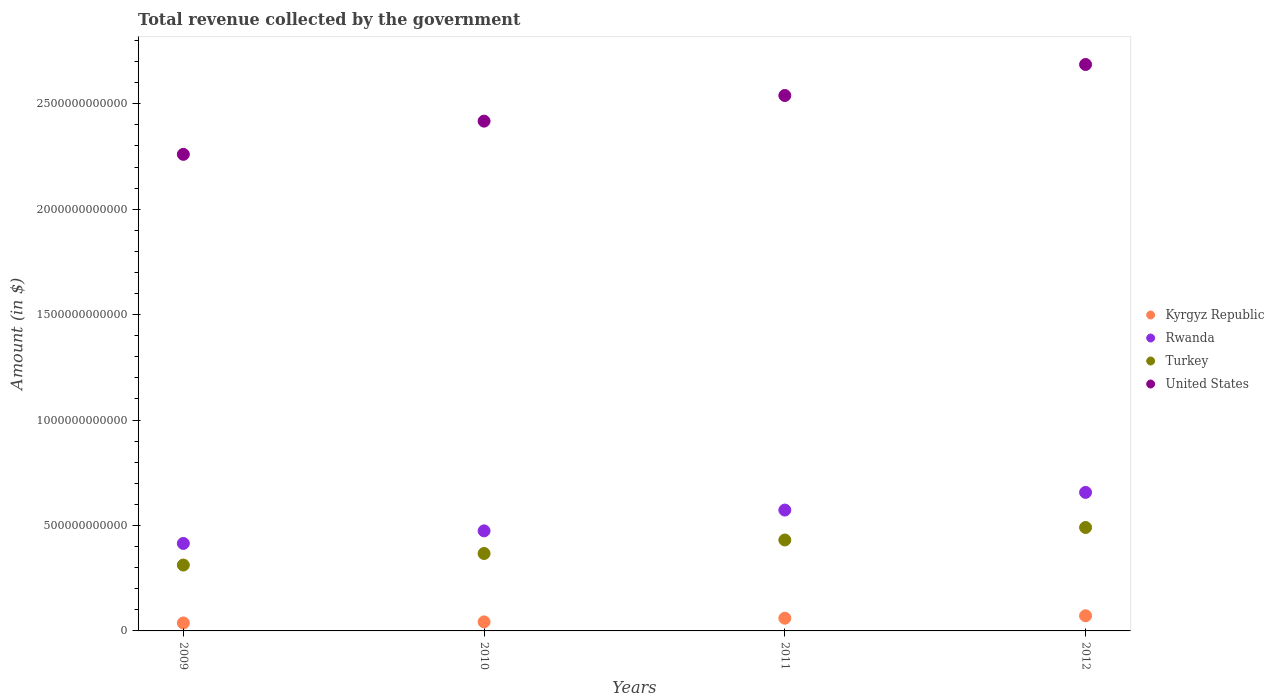How many different coloured dotlines are there?
Make the answer very short. 4. What is the total revenue collected by the government in Rwanda in 2010?
Provide a short and direct response. 4.75e+11. Across all years, what is the maximum total revenue collected by the government in Rwanda?
Your response must be concise. 6.57e+11. Across all years, what is the minimum total revenue collected by the government in Rwanda?
Provide a short and direct response. 4.15e+11. What is the total total revenue collected by the government in Rwanda in the graph?
Your answer should be very brief. 2.12e+12. What is the difference between the total revenue collected by the government in Kyrgyz Republic in 2009 and that in 2010?
Provide a succinct answer. -5.00e+09. What is the difference between the total revenue collected by the government in Kyrgyz Republic in 2011 and the total revenue collected by the government in United States in 2012?
Ensure brevity in your answer.  -2.63e+12. What is the average total revenue collected by the government in Rwanda per year?
Offer a terse response. 5.30e+11. In the year 2009, what is the difference between the total revenue collected by the government in Rwanda and total revenue collected by the government in Kyrgyz Republic?
Provide a short and direct response. 3.77e+11. In how many years, is the total revenue collected by the government in Rwanda greater than 1300000000000 $?
Ensure brevity in your answer.  0. What is the ratio of the total revenue collected by the government in Kyrgyz Republic in 2009 to that in 2012?
Make the answer very short. 0.53. Is the total revenue collected by the government in Kyrgyz Republic in 2009 less than that in 2012?
Your answer should be compact. Yes. What is the difference between the highest and the second highest total revenue collected by the government in Rwanda?
Provide a succinct answer. 8.38e+1. What is the difference between the highest and the lowest total revenue collected by the government in United States?
Make the answer very short. 4.26e+11. Is the sum of the total revenue collected by the government in United States in 2009 and 2010 greater than the maximum total revenue collected by the government in Turkey across all years?
Ensure brevity in your answer.  Yes. Is it the case that in every year, the sum of the total revenue collected by the government in Turkey and total revenue collected by the government in United States  is greater than the sum of total revenue collected by the government in Rwanda and total revenue collected by the government in Kyrgyz Republic?
Provide a short and direct response. Yes. Does the total revenue collected by the government in United States monotonically increase over the years?
Your response must be concise. Yes. Is the total revenue collected by the government in Rwanda strictly greater than the total revenue collected by the government in Kyrgyz Republic over the years?
Give a very brief answer. Yes. How many years are there in the graph?
Offer a very short reply. 4. What is the difference between two consecutive major ticks on the Y-axis?
Keep it short and to the point. 5.00e+11. Are the values on the major ticks of Y-axis written in scientific E-notation?
Offer a terse response. No. Does the graph contain any zero values?
Ensure brevity in your answer.  No. Where does the legend appear in the graph?
Provide a succinct answer. Center right. How are the legend labels stacked?
Your answer should be compact. Vertical. What is the title of the graph?
Make the answer very short. Total revenue collected by the government. What is the label or title of the X-axis?
Offer a terse response. Years. What is the label or title of the Y-axis?
Provide a succinct answer. Amount (in $). What is the Amount (in $) of Kyrgyz Republic in 2009?
Keep it short and to the point. 3.78e+1. What is the Amount (in $) in Rwanda in 2009?
Make the answer very short. 4.15e+11. What is the Amount (in $) in Turkey in 2009?
Give a very brief answer. 3.12e+11. What is the Amount (in $) of United States in 2009?
Offer a very short reply. 2.26e+12. What is the Amount (in $) of Kyrgyz Republic in 2010?
Provide a short and direct response. 4.28e+1. What is the Amount (in $) of Rwanda in 2010?
Give a very brief answer. 4.75e+11. What is the Amount (in $) in Turkey in 2010?
Your response must be concise. 3.67e+11. What is the Amount (in $) in United States in 2010?
Give a very brief answer. 2.42e+12. What is the Amount (in $) in Kyrgyz Republic in 2011?
Provide a succinct answer. 6.03e+1. What is the Amount (in $) of Rwanda in 2011?
Give a very brief answer. 5.73e+11. What is the Amount (in $) in Turkey in 2011?
Make the answer very short. 4.31e+11. What is the Amount (in $) of United States in 2011?
Give a very brief answer. 2.54e+12. What is the Amount (in $) in Kyrgyz Republic in 2012?
Ensure brevity in your answer.  7.19e+1. What is the Amount (in $) of Rwanda in 2012?
Offer a terse response. 6.57e+11. What is the Amount (in $) of Turkey in 2012?
Your answer should be very brief. 4.91e+11. What is the Amount (in $) in United States in 2012?
Your answer should be very brief. 2.69e+12. Across all years, what is the maximum Amount (in $) of Kyrgyz Republic?
Provide a short and direct response. 7.19e+1. Across all years, what is the maximum Amount (in $) in Rwanda?
Your response must be concise. 6.57e+11. Across all years, what is the maximum Amount (in $) in Turkey?
Your answer should be very brief. 4.91e+11. Across all years, what is the maximum Amount (in $) in United States?
Your answer should be very brief. 2.69e+12. Across all years, what is the minimum Amount (in $) of Kyrgyz Republic?
Keep it short and to the point. 3.78e+1. Across all years, what is the minimum Amount (in $) of Rwanda?
Ensure brevity in your answer.  4.15e+11. Across all years, what is the minimum Amount (in $) in Turkey?
Make the answer very short. 3.12e+11. Across all years, what is the minimum Amount (in $) in United States?
Keep it short and to the point. 2.26e+12. What is the total Amount (in $) in Kyrgyz Republic in the graph?
Provide a short and direct response. 2.13e+11. What is the total Amount (in $) of Rwanda in the graph?
Your response must be concise. 2.12e+12. What is the total Amount (in $) in Turkey in the graph?
Ensure brevity in your answer.  1.60e+12. What is the total Amount (in $) in United States in the graph?
Give a very brief answer. 9.90e+12. What is the difference between the Amount (in $) of Kyrgyz Republic in 2009 and that in 2010?
Keep it short and to the point. -5.00e+09. What is the difference between the Amount (in $) in Rwanda in 2009 and that in 2010?
Your answer should be compact. -5.97e+1. What is the difference between the Amount (in $) of Turkey in 2009 and that in 2010?
Your answer should be very brief. -5.48e+1. What is the difference between the Amount (in $) in United States in 2009 and that in 2010?
Your response must be concise. -1.58e+11. What is the difference between the Amount (in $) in Kyrgyz Republic in 2009 and that in 2011?
Provide a short and direct response. -2.25e+1. What is the difference between the Amount (in $) in Rwanda in 2009 and that in 2011?
Ensure brevity in your answer.  -1.58e+11. What is the difference between the Amount (in $) in Turkey in 2009 and that in 2011?
Provide a short and direct response. -1.19e+11. What is the difference between the Amount (in $) in United States in 2009 and that in 2011?
Your answer should be very brief. -2.79e+11. What is the difference between the Amount (in $) of Kyrgyz Republic in 2009 and that in 2012?
Keep it short and to the point. -3.41e+1. What is the difference between the Amount (in $) of Rwanda in 2009 and that in 2012?
Your answer should be compact. -2.42e+11. What is the difference between the Amount (in $) of Turkey in 2009 and that in 2012?
Your answer should be very brief. -1.78e+11. What is the difference between the Amount (in $) in United States in 2009 and that in 2012?
Keep it short and to the point. -4.26e+11. What is the difference between the Amount (in $) in Kyrgyz Republic in 2010 and that in 2011?
Your answer should be very brief. -1.75e+1. What is the difference between the Amount (in $) in Rwanda in 2010 and that in 2011?
Offer a terse response. -9.87e+1. What is the difference between the Amount (in $) of Turkey in 2010 and that in 2011?
Offer a very short reply. -6.41e+1. What is the difference between the Amount (in $) in United States in 2010 and that in 2011?
Your answer should be compact. -1.22e+11. What is the difference between the Amount (in $) of Kyrgyz Republic in 2010 and that in 2012?
Your response must be concise. -2.91e+1. What is the difference between the Amount (in $) in Rwanda in 2010 and that in 2012?
Give a very brief answer. -1.82e+11. What is the difference between the Amount (in $) of Turkey in 2010 and that in 2012?
Give a very brief answer. -1.23e+11. What is the difference between the Amount (in $) of United States in 2010 and that in 2012?
Give a very brief answer. -2.69e+11. What is the difference between the Amount (in $) of Kyrgyz Republic in 2011 and that in 2012?
Keep it short and to the point. -1.16e+1. What is the difference between the Amount (in $) of Rwanda in 2011 and that in 2012?
Your answer should be very brief. -8.38e+1. What is the difference between the Amount (in $) in Turkey in 2011 and that in 2012?
Keep it short and to the point. -5.93e+1. What is the difference between the Amount (in $) in United States in 2011 and that in 2012?
Offer a very short reply. -1.47e+11. What is the difference between the Amount (in $) of Kyrgyz Republic in 2009 and the Amount (in $) of Rwanda in 2010?
Keep it short and to the point. -4.37e+11. What is the difference between the Amount (in $) in Kyrgyz Republic in 2009 and the Amount (in $) in Turkey in 2010?
Provide a succinct answer. -3.29e+11. What is the difference between the Amount (in $) in Kyrgyz Republic in 2009 and the Amount (in $) in United States in 2010?
Keep it short and to the point. -2.38e+12. What is the difference between the Amount (in $) in Rwanda in 2009 and the Amount (in $) in Turkey in 2010?
Your answer should be compact. 4.77e+1. What is the difference between the Amount (in $) of Rwanda in 2009 and the Amount (in $) of United States in 2010?
Your response must be concise. -2.00e+12. What is the difference between the Amount (in $) of Turkey in 2009 and the Amount (in $) of United States in 2010?
Keep it short and to the point. -2.11e+12. What is the difference between the Amount (in $) in Kyrgyz Republic in 2009 and the Amount (in $) in Rwanda in 2011?
Your answer should be compact. -5.35e+11. What is the difference between the Amount (in $) in Kyrgyz Republic in 2009 and the Amount (in $) in Turkey in 2011?
Ensure brevity in your answer.  -3.93e+11. What is the difference between the Amount (in $) of Kyrgyz Republic in 2009 and the Amount (in $) of United States in 2011?
Your answer should be very brief. -2.50e+12. What is the difference between the Amount (in $) in Rwanda in 2009 and the Amount (in $) in Turkey in 2011?
Provide a short and direct response. -1.64e+1. What is the difference between the Amount (in $) of Rwanda in 2009 and the Amount (in $) of United States in 2011?
Ensure brevity in your answer.  -2.12e+12. What is the difference between the Amount (in $) of Turkey in 2009 and the Amount (in $) of United States in 2011?
Your answer should be compact. -2.23e+12. What is the difference between the Amount (in $) of Kyrgyz Republic in 2009 and the Amount (in $) of Rwanda in 2012?
Give a very brief answer. -6.19e+11. What is the difference between the Amount (in $) in Kyrgyz Republic in 2009 and the Amount (in $) in Turkey in 2012?
Make the answer very short. -4.53e+11. What is the difference between the Amount (in $) in Kyrgyz Republic in 2009 and the Amount (in $) in United States in 2012?
Your answer should be compact. -2.65e+12. What is the difference between the Amount (in $) of Rwanda in 2009 and the Amount (in $) of Turkey in 2012?
Provide a succinct answer. -7.57e+1. What is the difference between the Amount (in $) of Rwanda in 2009 and the Amount (in $) of United States in 2012?
Provide a short and direct response. -2.27e+12. What is the difference between the Amount (in $) in Turkey in 2009 and the Amount (in $) in United States in 2012?
Ensure brevity in your answer.  -2.37e+12. What is the difference between the Amount (in $) of Kyrgyz Republic in 2010 and the Amount (in $) of Rwanda in 2011?
Offer a terse response. -5.30e+11. What is the difference between the Amount (in $) in Kyrgyz Republic in 2010 and the Amount (in $) in Turkey in 2011?
Your answer should be compact. -3.88e+11. What is the difference between the Amount (in $) in Kyrgyz Republic in 2010 and the Amount (in $) in United States in 2011?
Provide a short and direct response. -2.50e+12. What is the difference between the Amount (in $) in Rwanda in 2010 and the Amount (in $) in Turkey in 2011?
Your response must be concise. 4.33e+1. What is the difference between the Amount (in $) of Rwanda in 2010 and the Amount (in $) of United States in 2011?
Your answer should be compact. -2.06e+12. What is the difference between the Amount (in $) in Turkey in 2010 and the Amount (in $) in United States in 2011?
Make the answer very short. -2.17e+12. What is the difference between the Amount (in $) of Kyrgyz Republic in 2010 and the Amount (in $) of Rwanda in 2012?
Provide a short and direct response. -6.14e+11. What is the difference between the Amount (in $) in Kyrgyz Republic in 2010 and the Amount (in $) in Turkey in 2012?
Make the answer very short. -4.48e+11. What is the difference between the Amount (in $) of Kyrgyz Republic in 2010 and the Amount (in $) of United States in 2012?
Provide a succinct answer. -2.64e+12. What is the difference between the Amount (in $) in Rwanda in 2010 and the Amount (in $) in Turkey in 2012?
Provide a short and direct response. -1.60e+1. What is the difference between the Amount (in $) of Rwanda in 2010 and the Amount (in $) of United States in 2012?
Your answer should be compact. -2.21e+12. What is the difference between the Amount (in $) in Turkey in 2010 and the Amount (in $) in United States in 2012?
Your response must be concise. -2.32e+12. What is the difference between the Amount (in $) in Kyrgyz Republic in 2011 and the Amount (in $) in Rwanda in 2012?
Keep it short and to the point. -5.97e+11. What is the difference between the Amount (in $) in Kyrgyz Republic in 2011 and the Amount (in $) in Turkey in 2012?
Make the answer very short. -4.30e+11. What is the difference between the Amount (in $) in Kyrgyz Republic in 2011 and the Amount (in $) in United States in 2012?
Ensure brevity in your answer.  -2.63e+12. What is the difference between the Amount (in $) of Rwanda in 2011 and the Amount (in $) of Turkey in 2012?
Offer a very short reply. 8.27e+1. What is the difference between the Amount (in $) of Rwanda in 2011 and the Amount (in $) of United States in 2012?
Give a very brief answer. -2.11e+12. What is the difference between the Amount (in $) of Turkey in 2011 and the Amount (in $) of United States in 2012?
Provide a succinct answer. -2.26e+12. What is the average Amount (in $) of Kyrgyz Republic per year?
Offer a terse response. 5.32e+1. What is the average Amount (in $) of Rwanda per year?
Offer a terse response. 5.30e+11. What is the average Amount (in $) of Turkey per year?
Keep it short and to the point. 4.00e+11. What is the average Amount (in $) of United States per year?
Offer a terse response. 2.48e+12. In the year 2009, what is the difference between the Amount (in $) in Kyrgyz Republic and Amount (in $) in Rwanda?
Your answer should be compact. -3.77e+11. In the year 2009, what is the difference between the Amount (in $) in Kyrgyz Republic and Amount (in $) in Turkey?
Ensure brevity in your answer.  -2.75e+11. In the year 2009, what is the difference between the Amount (in $) in Kyrgyz Republic and Amount (in $) in United States?
Ensure brevity in your answer.  -2.22e+12. In the year 2009, what is the difference between the Amount (in $) of Rwanda and Amount (in $) of Turkey?
Keep it short and to the point. 1.02e+11. In the year 2009, what is the difference between the Amount (in $) of Rwanda and Amount (in $) of United States?
Offer a terse response. -1.85e+12. In the year 2009, what is the difference between the Amount (in $) in Turkey and Amount (in $) in United States?
Offer a terse response. -1.95e+12. In the year 2010, what is the difference between the Amount (in $) of Kyrgyz Republic and Amount (in $) of Rwanda?
Provide a short and direct response. -4.32e+11. In the year 2010, what is the difference between the Amount (in $) of Kyrgyz Republic and Amount (in $) of Turkey?
Your response must be concise. -3.24e+11. In the year 2010, what is the difference between the Amount (in $) in Kyrgyz Republic and Amount (in $) in United States?
Your response must be concise. -2.37e+12. In the year 2010, what is the difference between the Amount (in $) in Rwanda and Amount (in $) in Turkey?
Give a very brief answer. 1.07e+11. In the year 2010, what is the difference between the Amount (in $) in Rwanda and Amount (in $) in United States?
Your response must be concise. -1.94e+12. In the year 2010, what is the difference between the Amount (in $) in Turkey and Amount (in $) in United States?
Provide a succinct answer. -2.05e+12. In the year 2011, what is the difference between the Amount (in $) of Kyrgyz Republic and Amount (in $) of Rwanda?
Offer a very short reply. -5.13e+11. In the year 2011, what is the difference between the Amount (in $) of Kyrgyz Republic and Amount (in $) of Turkey?
Your response must be concise. -3.71e+11. In the year 2011, what is the difference between the Amount (in $) of Kyrgyz Republic and Amount (in $) of United States?
Offer a terse response. -2.48e+12. In the year 2011, what is the difference between the Amount (in $) in Rwanda and Amount (in $) in Turkey?
Your answer should be very brief. 1.42e+11. In the year 2011, what is the difference between the Amount (in $) of Rwanda and Amount (in $) of United States?
Make the answer very short. -1.97e+12. In the year 2011, what is the difference between the Amount (in $) in Turkey and Amount (in $) in United States?
Your response must be concise. -2.11e+12. In the year 2012, what is the difference between the Amount (in $) in Kyrgyz Republic and Amount (in $) in Rwanda?
Offer a terse response. -5.85e+11. In the year 2012, what is the difference between the Amount (in $) of Kyrgyz Republic and Amount (in $) of Turkey?
Your response must be concise. -4.19e+11. In the year 2012, what is the difference between the Amount (in $) of Kyrgyz Republic and Amount (in $) of United States?
Your answer should be compact. -2.61e+12. In the year 2012, what is the difference between the Amount (in $) in Rwanda and Amount (in $) in Turkey?
Provide a short and direct response. 1.66e+11. In the year 2012, what is the difference between the Amount (in $) of Rwanda and Amount (in $) of United States?
Offer a terse response. -2.03e+12. In the year 2012, what is the difference between the Amount (in $) of Turkey and Amount (in $) of United States?
Your answer should be compact. -2.20e+12. What is the ratio of the Amount (in $) of Kyrgyz Republic in 2009 to that in 2010?
Make the answer very short. 0.88. What is the ratio of the Amount (in $) in Rwanda in 2009 to that in 2010?
Provide a short and direct response. 0.87. What is the ratio of the Amount (in $) in Turkey in 2009 to that in 2010?
Provide a short and direct response. 0.85. What is the ratio of the Amount (in $) of United States in 2009 to that in 2010?
Offer a very short reply. 0.93. What is the ratio of the Amount (in $) in Kyrgyz Republic in 2009 to that in 2011?
Provide a succinct answer. 0.63. What is the ratio of the Amount (in $) of Rwanda in 2009 to that in 2011?
Provide a short and direct response. 0.72. What is the ratio of the Amount (in $) in Turkey in 2009 to that in 2011?
Provide a succinct answer. 0.72. What is the ratio of the Amount (in $) in United States in 2009 to that in 2011?
Provide a short and direct response. 0.89. What is the ratio of the Amount (in $) of Kyrgyz Republic in 2009 to that in 2012?
Offer a very short reply. 0.53. What is the ratio of the Amount (in $) in Rwanda in 2009 to that in 2012?
Ensure brevity in your answer.  0.63. What is the ratio of the Amount (in $) in Turkey in 2009 to that in 2012?
Offer a terse response. 0.64. What is the ratio of the Amount (in $) of United States in 2009 to that in 2012?
Your answer should be compact. 0.84. What is the ratio of the Amount (in $) of Kyrgyz Republic in 2010 to that in 2011?
Give a very brief answer. 0.71. What is the ratio of the Amount (in $) of Rwanda in 2010 to that in 2011?
Offer a terse response. 0.83. What is the ratio of the Amount (in $) of Turkey in 2010 to that in 2011?
Your answer should be compact. 0.85. What is the ratio of the Amount (in $) in United States in 2010 to that in 2011?
Your response must be concise. 0.95. What is the ratio of the Amount (in $) in Kyrgyz Republic in 2010 to that in 2012?
Offer a terse response. 0.6. What is the ratio of the Amount (in $) in Rwanda in 2010 to that in 2012?
Your response must be concise. 0.72. What is the ratio of the Amount (in $) in Turkey in 2010 to that in 2012?
Provide a succinct answer. 0.75. What is the ratio of the Amount (in $) in Kyrgyz Republic in 2011 to that in 2012?
Your answer should be very brief. 0.84. What is the ratio of the Amount (in $) of Rwanda in 2011 to that in 2012?
Your response must be concise. 0.87. What is the ratio of the Amount (in $) of Turkey in 2011 to that in 2012?
Make the answer very short. 0.88. What is the ratio of the Amount (in $) of United States in 2011 to that in 2012?
Provide a succinct answer. 0.95. What is the difference between the highest and the second highest Amount (in $) in Kyrgyz Republic?
Keep it short and to the point. 1.16e+1. What is the difference between the highest and the second highest Amount (in $) of Rwanda?
Make the answer very short. 8.38e+1. What is the difference between the highest and the second highest Amount (in $) in Turkey?
Give a very brief answer. 5.93e+1. What is the difference between the highest and the second highest Amount (in $) in United States?
Keep it short and to the point. 1.47e+11. What is the difference between the highest and the lowest Amount (in $) of Kyrgyz Republic?
Offer a terse response. 3.41e+1. What is the difference between the highest and the lowest Amount (in $) of Rwanda?
Make the answer very short. 2.42e+11. What is the difference between the highest and the lowest Amount (in $) in Turkey?
Provide a succinct answer. 1.78e+11. What is the difference between the highest and the lowest Amount (in $) in United States?
Your answer should be compact. 4.26e+11. 